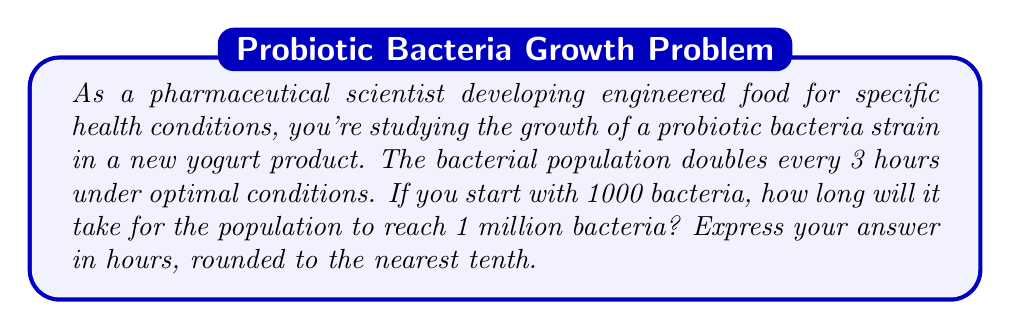Could you help me with this problem? Let's approach this step-by-step using logarithms:

1) First, let's define our variables:
   $N_0 = 1000$ (initial population)
   $N = 1,000,000$ (final population)
   $t$ = time in hours (what we're solving for)

2) We know the population doubles every 3 hours. This means we can express the growth as:
   $N = N_0 \cdot 2^{\frac{t}{3}}$

3) Substituting our known values:
   $1,000,000 = 1000 \cdot 2^{\frac{t}{3}}$

4) Simplify:
   $1000 = 2^{\frac{t}{3}}$

5) Now, let's take the logarithm (base 2) of both sides:
   $\log_2(1000) = \log_2(2^{\frac{t}{3}})$

6) The right side simplifies due to the logarithm rule $\log_a(a^x) = x$:
   $\log_2(1000) = \frac{t}{3}$

7) Solve for $t$:
   $t = 3 \cdot \log_2(1000)$

8) Calculate:
   $t = 3 \cdot \frac{\log(1000)}{\log(2)}$ (changing to natural log for calculator use)
   $t = 3 \cdot \frac{6.9077552789821}{0.6931471805599}$
   $t \approx 29.897$ hours

9) Rounding to the nearest tenth:
   $t \approx 29.9$ hours
Answer: 29.9 hours 